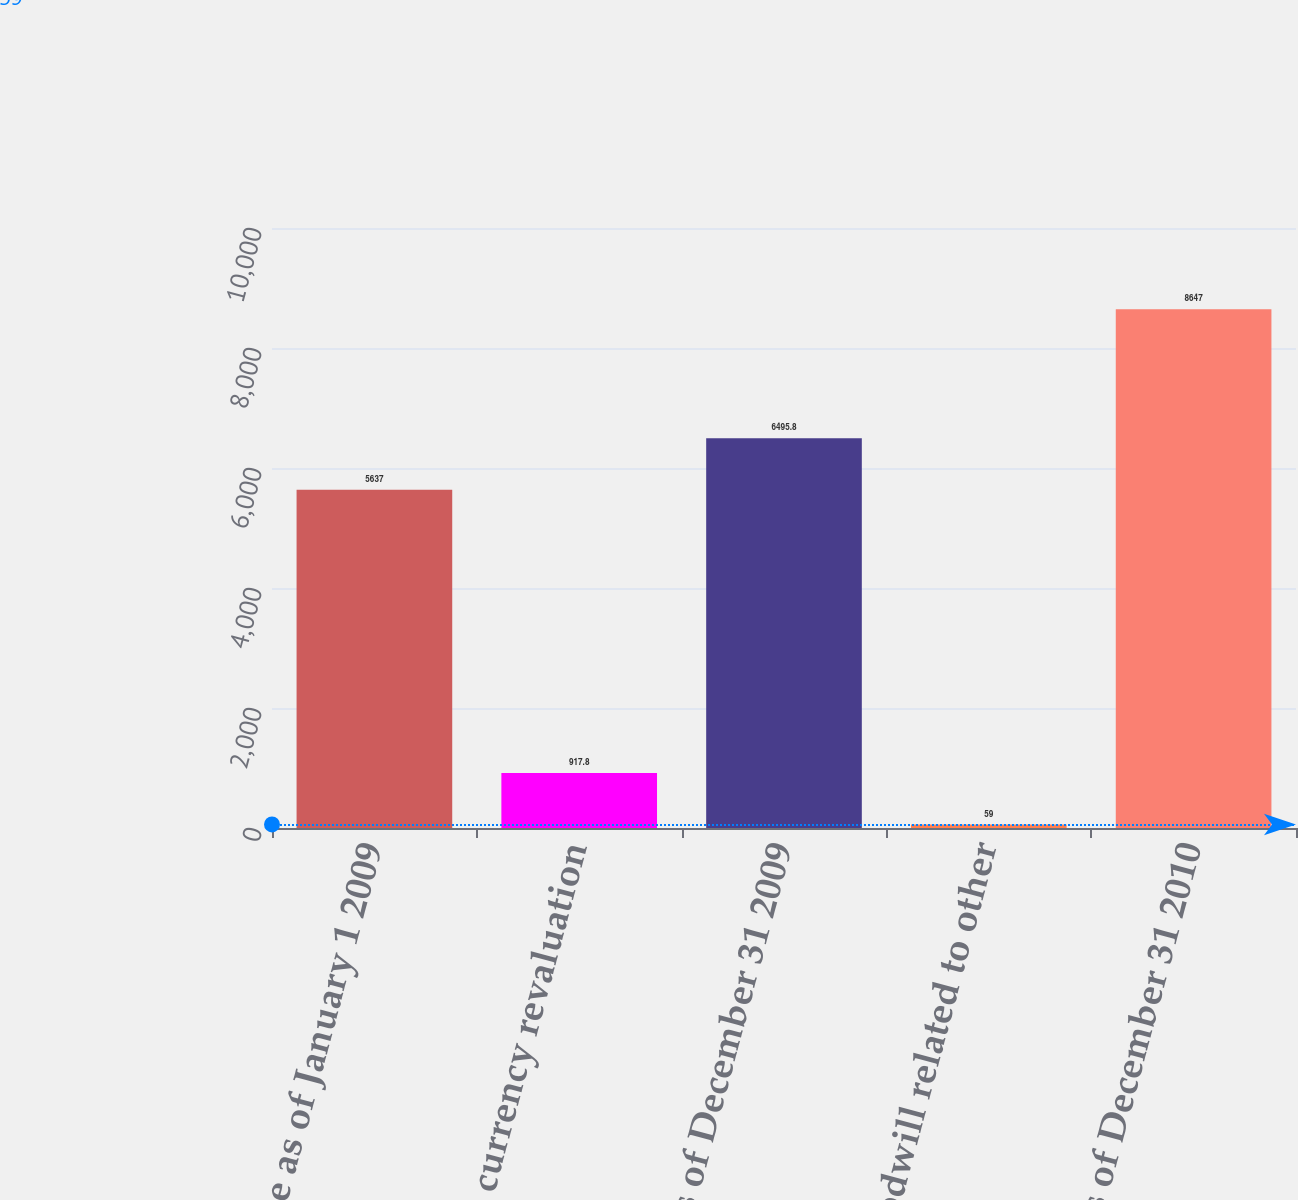Convert chart. <chart><loc_0><loc_0><loc_500><loc_500><bar_chart><fcel>Balance as of January 1 2009<fcel>Foreign currency revaluation<fcel>Balance as of December 31 2009<fcel>Goodwill related to other<fcel>Balance as of December 31 2010<nl><fcel>5637<fcel>917.8<fcel>6495.8<fcel>59<fcel>8647<nl></chart> 